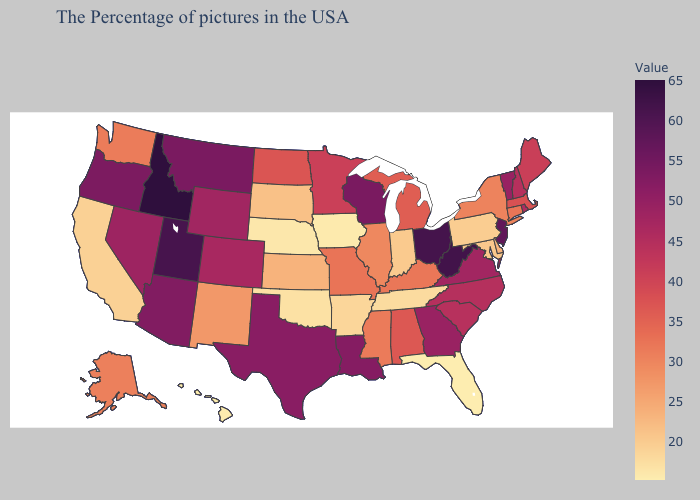Does Florida have the lowest value in the South?
Keep it brief. Yes. Among the states that border Arkansas , does Tennessee have the lowest value?
Short answer required. No. Does South Dakota have the highest value in the USA?
Keep it brief. No. Among the states that border Ohio , which have the highest value?
Write a very short answer. West Virginia. 